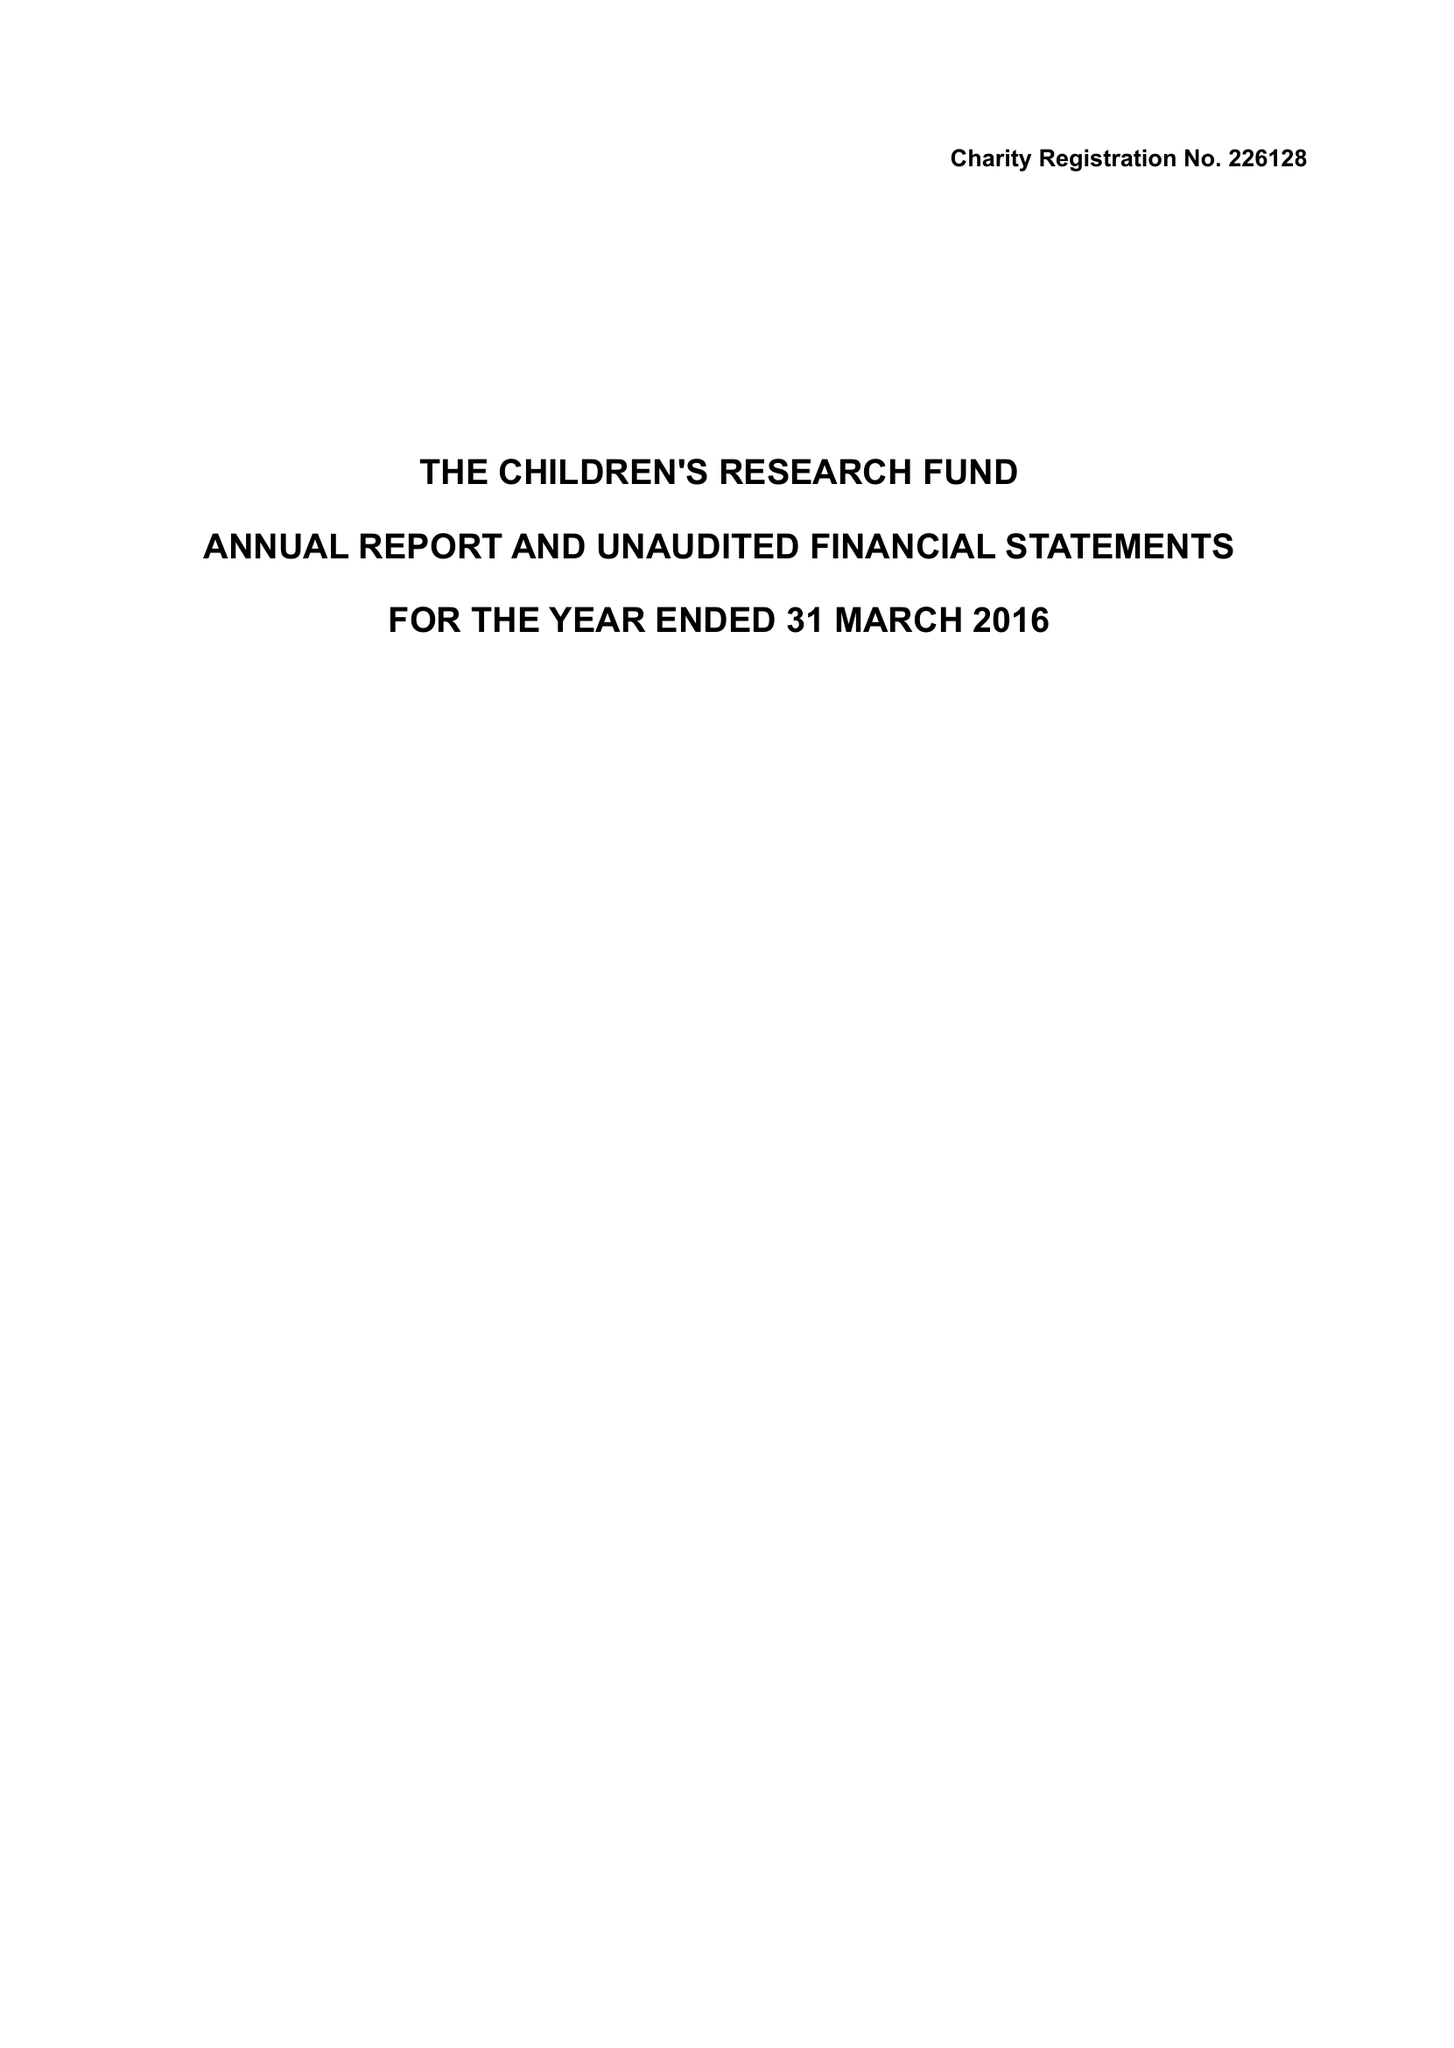What is the value for the charity_name?
Answer the question using a single word or phrase. The Children's Research Fund 